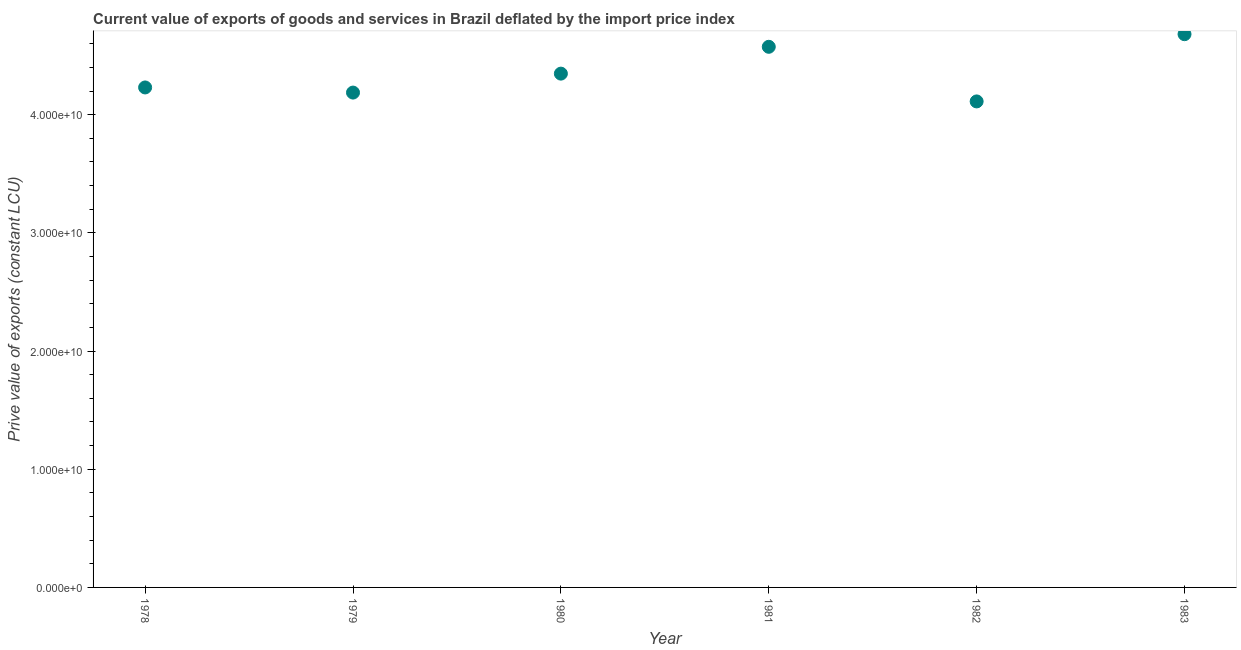What is the price value of exports in 1979?
Make the answer very short. 4.19e+1. Across all years, what is the maximum price value of exports?
Your answer should be compact. 4.68e+1. Across all years, what is the minimum price value of exports?
Make the answer very short. 4.11e+1. In which year was the price value of exports minimum?
Provide a succinct answer. 1982. What is the sum of the price value of exports?
Your answer should be very brief. 2.61e+11. What is the difference between the price value of exports in 1981 and 1983?
Give a very brief answer. -1.07e+09. What is the average price value of exports per year?
Your answer should be very brief. 4.36e+1. What is the median price value of exports?
Provide a succinct answer. 4.29e+1. Do a majority of the years between 1978 and 1981 (inclusive) have price value of exports greater than 4000000000 LCU?
Provide a succinct answer. Yes. What is the ratio of the price value of exports in 1981 to that in 1983?
Ensure brevity in your answer.  0.98. Is the price value of exports in 1979 less than that in 1981?
Offer a very short reply. Yes. What is the difference between the highest and the second highest price value of exports?
Offer a very short reply. 1.07e+09. What is the difference between the highest and the lowest price value of exports?
Make the answer very short. 5.69e+09. Does the price value of exports monotonically increase over the years?
Offer a very short reply. No. How many dotlines are there?
Offer a terse response. 1. What is the difference between two consecutive major ticks on the Y-axis?
Offer a very short reply. 1.00e+1. Are the values on the major ticks of Y-axis written in scientific E-notation?
Offer a terse response. Yes. What is the title of the graph?
Make the answer very short. Current value of exports of goods and services in Brazil deflated by the import price index. What is the label or title of the X-axis?
Offer a very short reply. Year. What is the label or title of the Y-axis?
Provide a succinct answer. Prive value of exports (constant LCU). What is the Prive value of exports (constant LCU) in 1978?
Give a very brief answer. 4.23e+1. What is the Prive value of exports (constant LCU) in 1979?
Your response must be concise. 4.19e+1. What is the Prive value of exports (constant LCU) in 1980?
Provide a short and direct response. 4.35e+1. What is the Prive value of exports (constant LCU) in 1981?
Keep it short and to the point. 4.57e+1. What is the Prive value of exports (constant LCU) in 1982?
Your answer should be compact. 4.11e+1. What is the Prive value of exports (constant LCU) in 1983?
Give a very brief answer. 4.68e+1. What is the difference between the Prive value of exports (constant LCU) in 1978 and 1979?
Make the answer very short. 4.34e+08. What is the difference between the Prive value of exports (constant LCU) in 1978 and 1980?
Keep it short and to the point. -1.17e+09. What is the difference between the Prive value of exports (constant LCU) in 1978 and 1981?
Your answer should be very brief. -3.44e+09. What is the difference between the Prive value of exports (constant LCU) in 1978 and 1982?
Give a very brief answer. 1.18e+09. What is the difference between the Prive value of exports (constant LCU) in 1978 and 1983?
Ensure brevity in your answer.  -4.51e+09. What is the difference between the Prive value of exports (constant LCU) in 1979 and 1980?
Give a very brief answer. -1.60e+09. What is the difference between the Prive value of exports (constant LCU) in 1979 and 1981?
Give a very brief answer. -3.87e+09. What is the difference between the Prive value of exports (constant LCU) in 1979 and 1982?
Provide a short and direct response. 7.48e+08. What is the difference between the Prive value of exports (constant LCU) in 1979 and 1983?
Keep it short and to the point. -4.94e+09. What is the difference between the Prive value of exports (constant LCU) in 1980 and 1981?
Provide a short and direct response. -2.27e+09. What is the difference between the Prive value of exports (constant LCU) in 1980 and 1982?
Your response must be concise. 2.35e+09. What is the difference between the Prive value of exports (constant LCU) in 1980 and 1983?
Make the answer very short. -3.34e+09. What is the difference between the Prive value of exports (constant LCU) in 1981 and 1982?
Keep it short and to the point. 4.62e+09. What is the difference between the Prive value of exports (constant LCU) in 1981 and 1983?
Your response must be concise. -1.07e+09. What is the difference between the Prive value of exports (constant LCU) in 1982 and 1983?
Provide a short and direct response. -5.69e+09. What is the ratio of the Prive value of exports (constant LCU) in 1978 to that in 1979?
Make the answer very short. 1.01. What is the ratio of the Prive value of exports (constant LCU) in 1978 to that in 1981?
Keep it short and to the point. 0.93. What is the ratio of the Prive value of exports (constant LCU) in 1978 to that in 1983?
Your answer should be very brief. 0.9. What is the ratio of the Prive value of exports (constant LCU) in 1979 to that in 1980?
Your answer should be very brief. 0.96. What is the ratio of the Prive value of exports (constant LCU) in 1979 to that in 1981?
Your answer should be compact. 0.92. What is the ratio of the Prive value of exports (constant LCU) in 1979 to that in 1983?
Your answer should be very brief. 0.89. What is the ratio of the Prive value of exports (constant LCU) in 1980 to that in 1981?
Provide a short and direct response. 0.95. What is the ratio of the Prive value of exports (constant LCU) in 1980 to that in 1982?
Your answer should be very brief. 1.06. What is the ratio of the Prive value of exports (constant LCU) in 1980 to that in 1983?
Ensure brevity in your answer.  0.93. What is the ratio of the Prive value of exports (constant LCU) in 1981 to that in 1982?
Ensure brevity in your answer.  1.11. What is the ratio of the Prive value of exports (constant LCU) in 1981 to that in 1983?
Your answer should be compact. 0.98. What is the ratio of the Prive value of exports (constant LCU) in 1982 to that in 1983?
Your response must be concise. 0.88. 